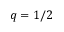<formula> <loc_0><loc_0><loc_500><loc_500>q = 1 / 2</formula> 